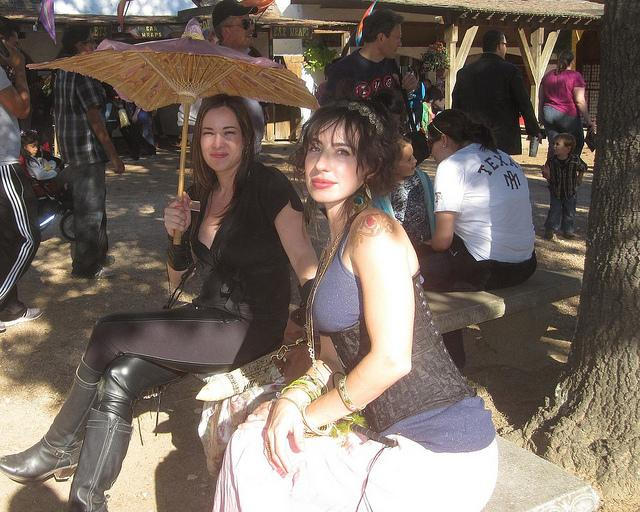The umbrella is made of what material? Please explain your reasoning. bamboo. The umbrella is made of wood. a is the only option which is a type of wood. 